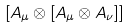Convert formula to latex. <formula><loc_0><loc_0><loc_500><loc_500>\left [ A _ { \mu } \otimes \left [ A _ { \mu } \otimes A _ { \nu } \right ] \right ]</formula> 